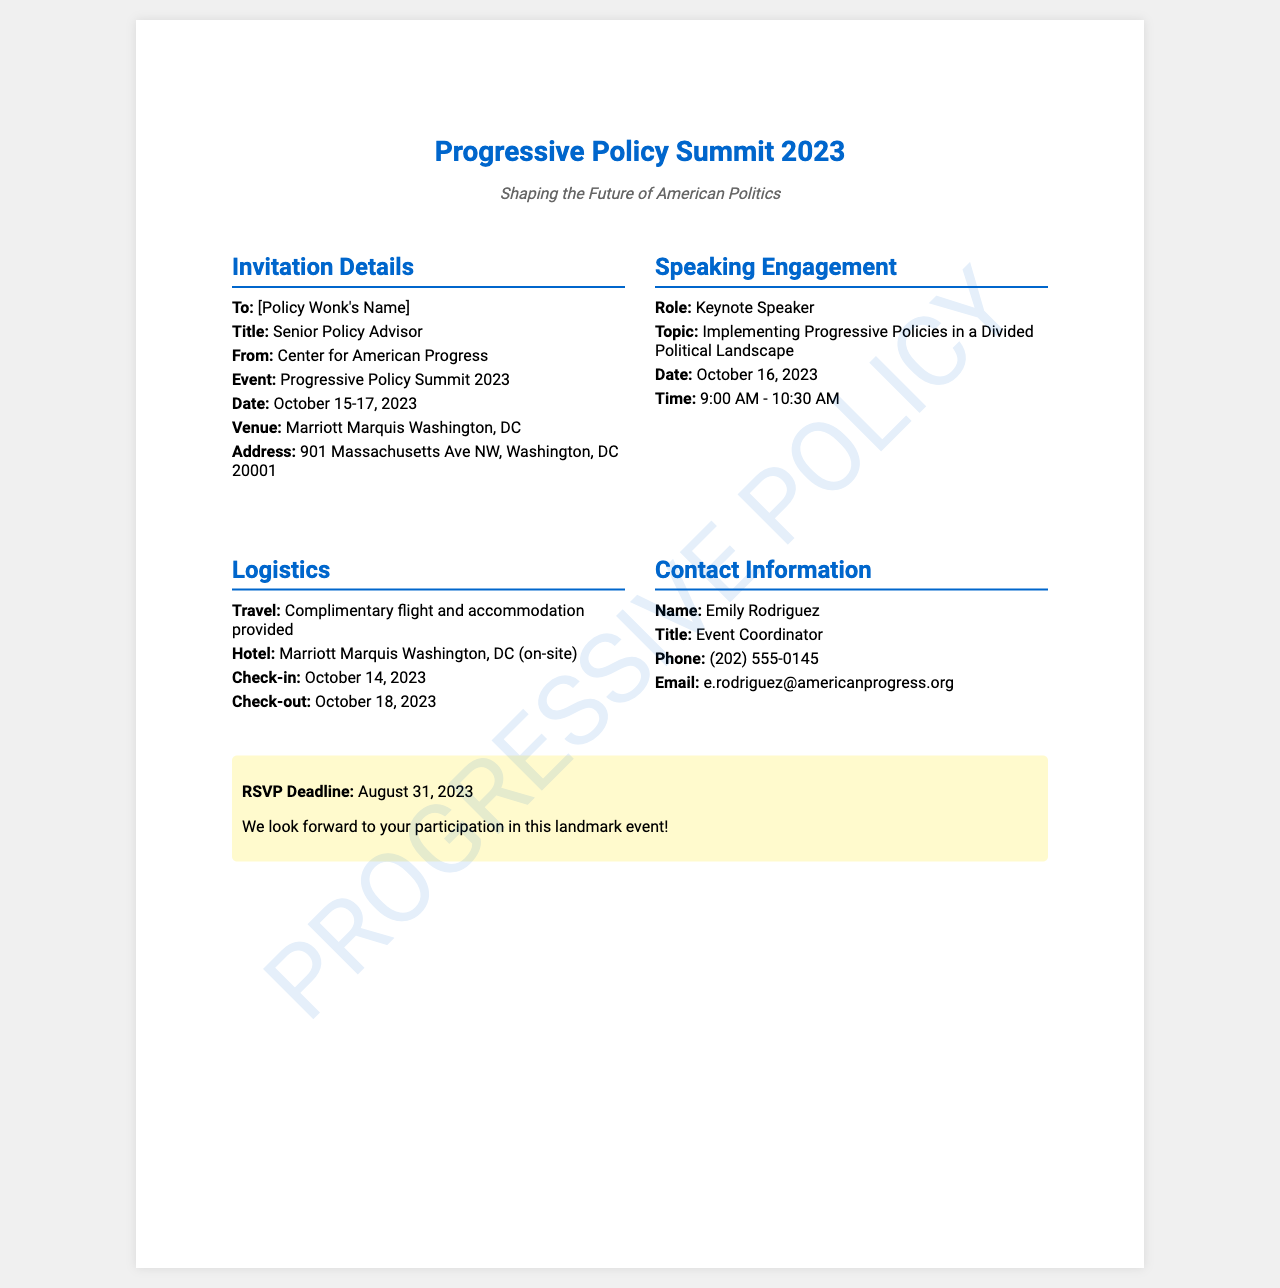What is the event date? The event date is mentioned in the document as October 15-17, 2023.
Answer: October 15-17, 2023 Who is the keynote speaker? The keynote speaker is specified in the document under speaking engagement details.
Answer: [Policy Wonk's Name] What is the speaking topic? The topic of the speaking engagement is detailed in the fax under the speaking engagement section.
Answer: Implementing Progressive Policies in a Divided Political Landscape What time does the keynote speech start? The time for the keynote speech is provided in the speaking engagement section of the document.
Answer: 9:00 AM Who is the event coordinator? The event coordinator's name is listed in the contact information section of the fax.
Answer: Emily Rodriguez What is the RSVP deadline? The RSVP deadline is highlighted at the bottom of the fax, indicating when responses are due.
Answer: August 31, 2023 What hotel will be used for accommodation? The hotel information is included in the logistics section of the fax.
Answer: Marriott Marquis Washington, DC When is the check-in date? The check-in date is provided in the logistics section, specifying when attendees should arrive.
Answer: October 14, 2023 What is included with travel arrangements? The travel arrangements section mentions specifics about what is provided.
Answer: Complimentary flight and accommodation provided 